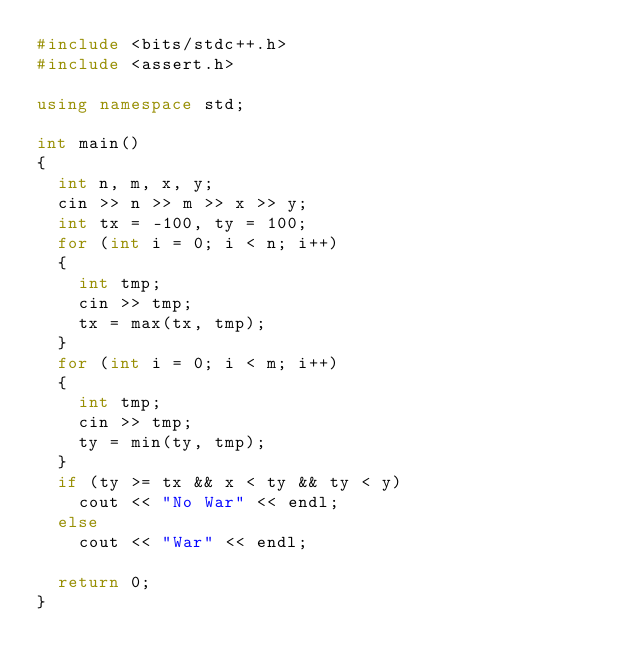Convert code to text. <code><loc_0><loc_0><loc_500><loc_500><_C++_>#include <bits/stdc++.h>
#include <assert.h>

using namespace std;

int main()
{
  int n, m, x, y;
  cin >> n >> m >> x >> y;
  int tx = -100, ty = 100;
  for (int i = 0; i < n; i++)
  {
    int tmp;
    cin >> tmp;
    tx = max(tx, tmp);
  }
  for (int i = 0; i < m; i++)
  {
    int tmp;
    cin >> tmp;
    ty = min(ty, tmp);
  }
  if (ty >= tx && x < ty && ty < y)
    cout << "No War" << endl;
  else
    cout << "War" << endl;

  return 0;
}
</code> 